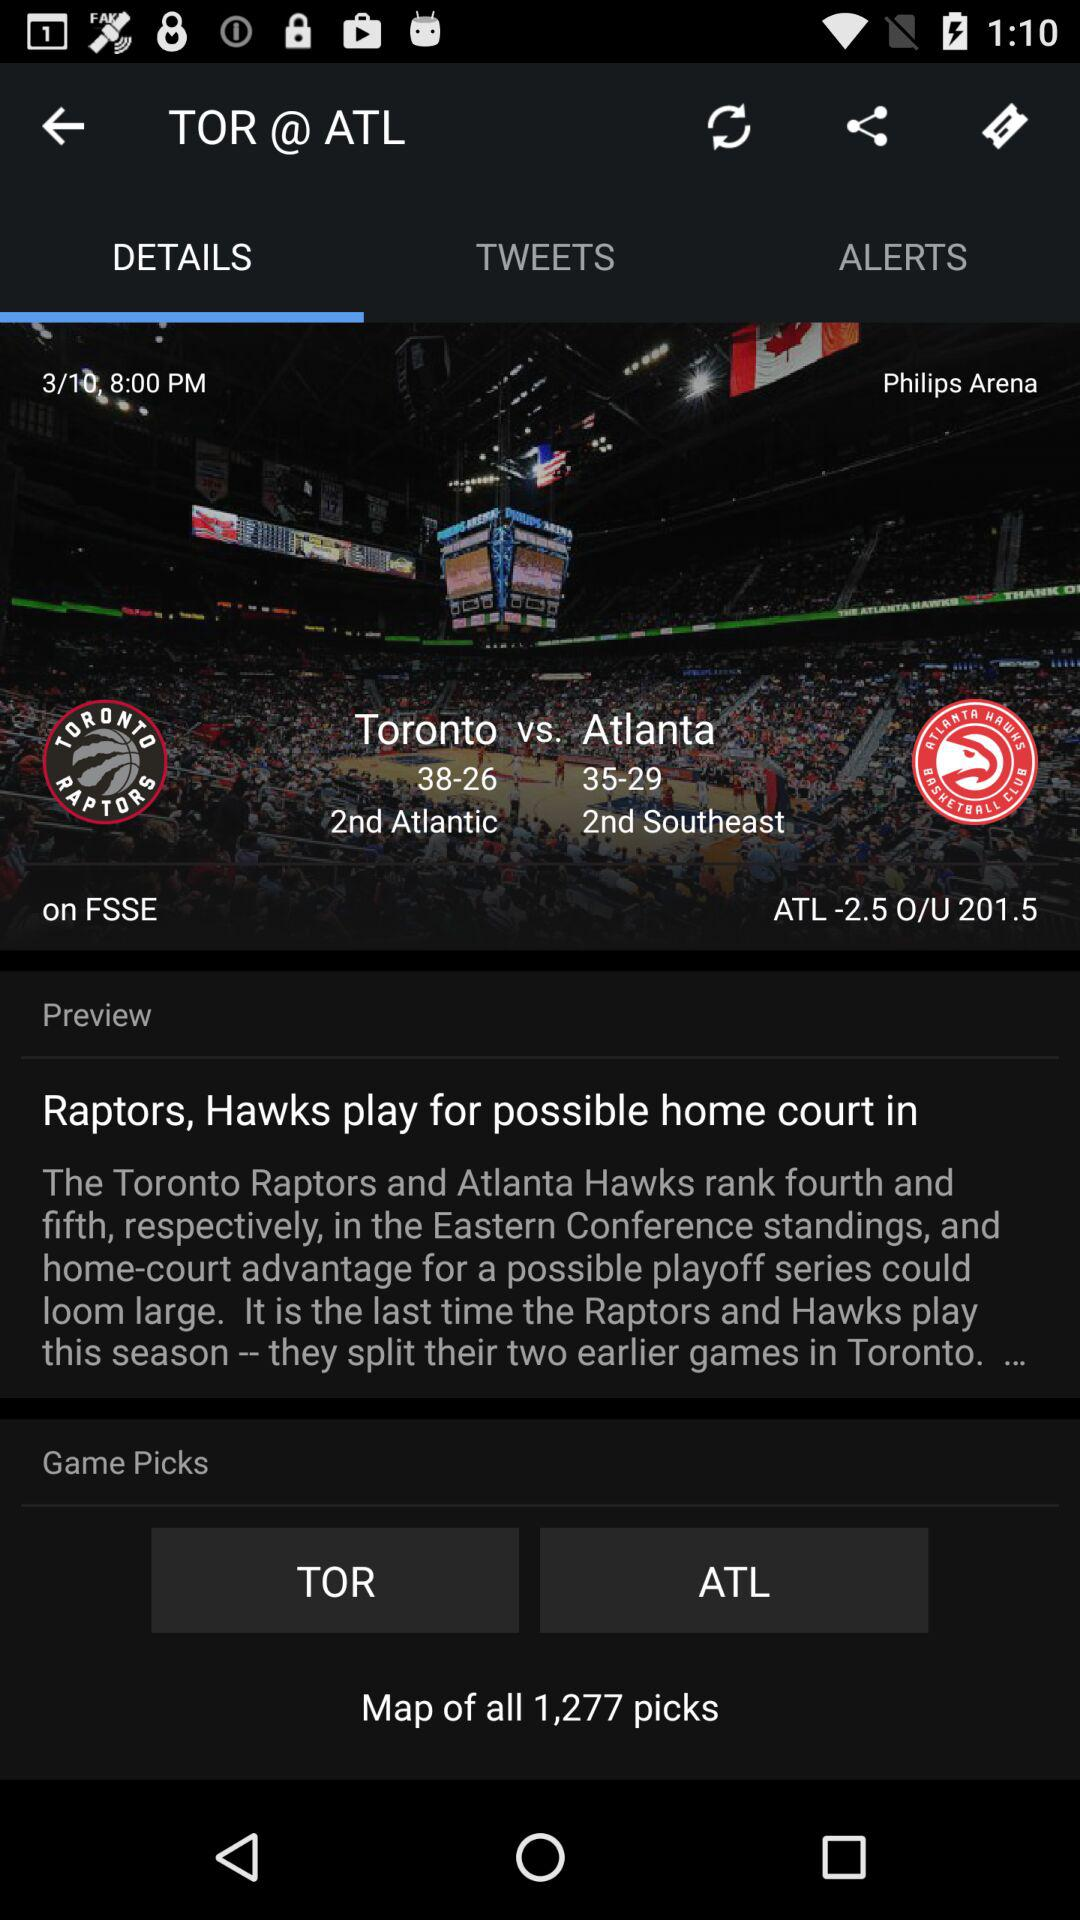Which tab is selected? The selected tab is "DETAILS". 